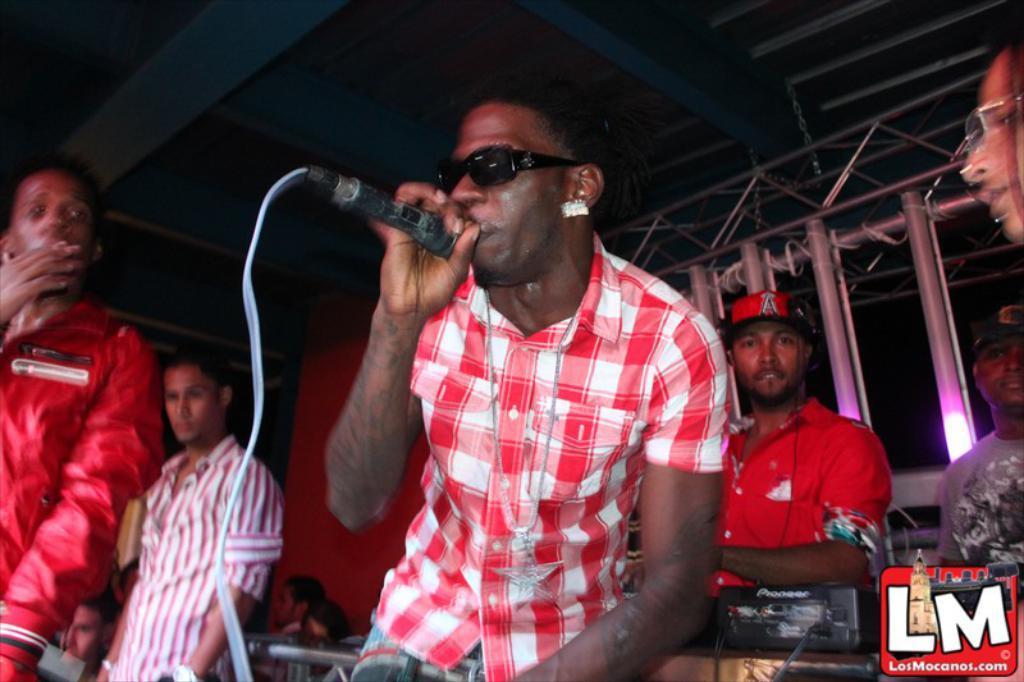Please provide a concise description of this image. In this image I can see number of people are standing and in the front I can see one of them is holding a mic, I can also see he is wearing black shades. On the right side of this image I can see two men are wearing caps and one woman is wearing a specs. In the background I can see few poles, few lights and on the bottom side I can see a black colour thing. I can also see a watermark on the bottom right side of this image. 